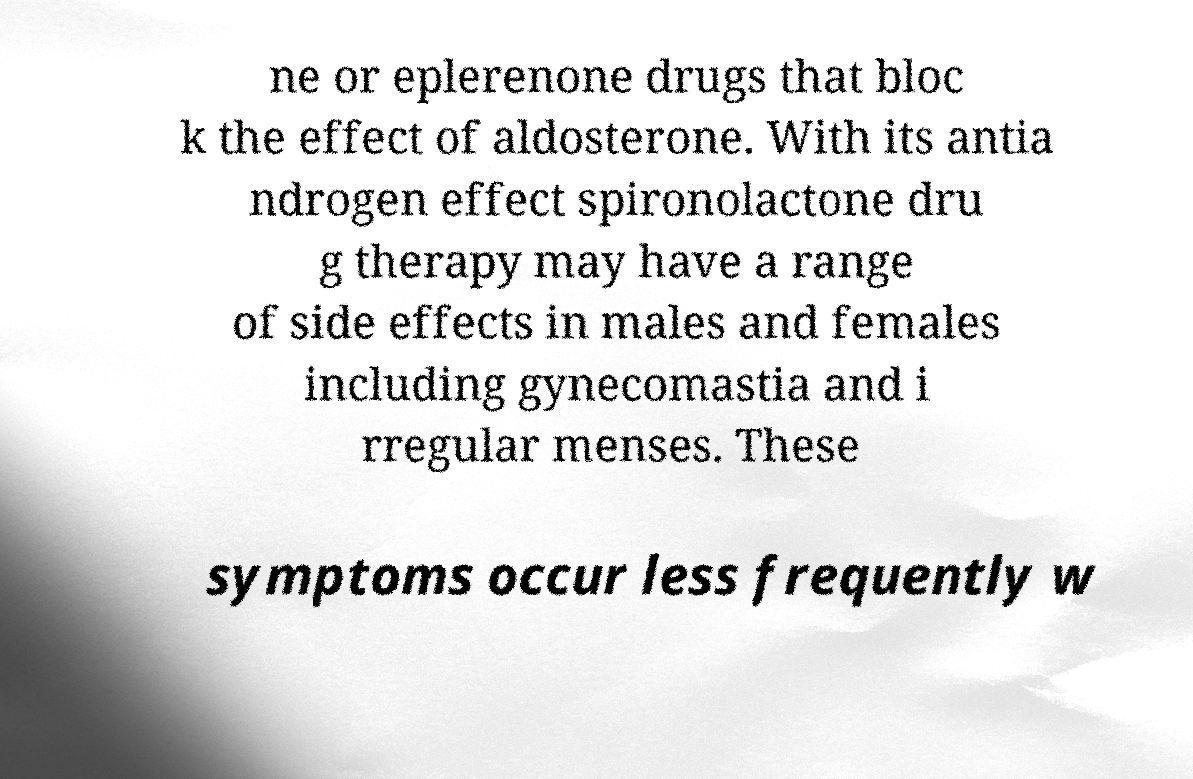Can you read and provide the text displayed in the image?This photo seems to have some interesting text. Can you extract and type it out for me? ne or eplerenone drugs that bloc k the effect of aldosterone. With its antia ndrogen effect spironolactone dru g therapy may have a range of side effects in males and females including gynecomastia and i rregular menses. These symptoms occur less frequently w 